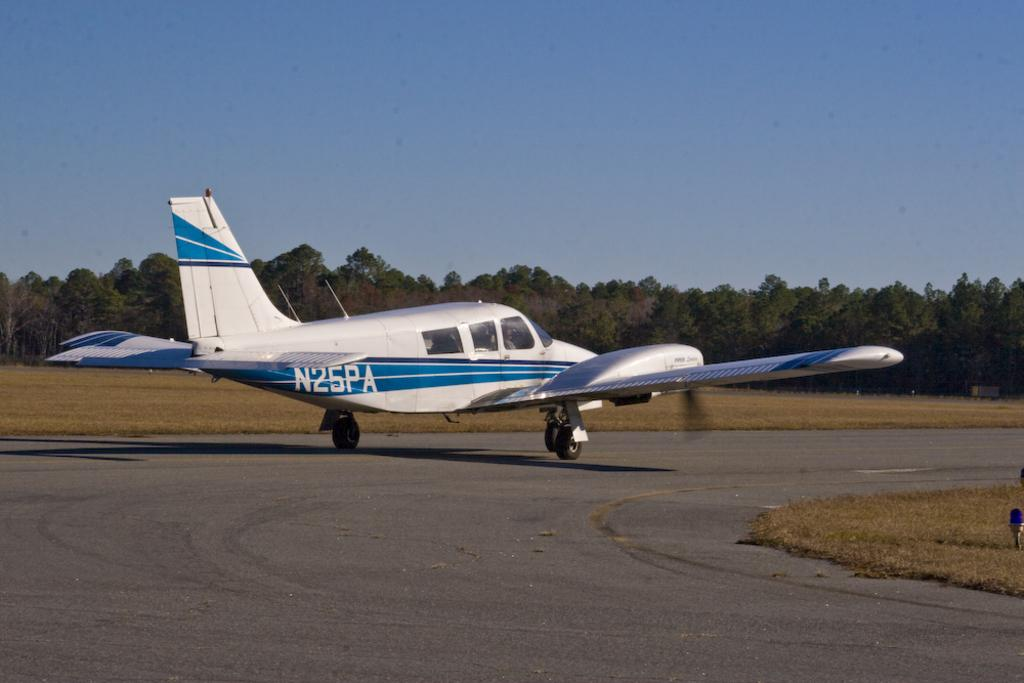What is the main subject of the image? The main subject of the image is an airplane. Can you describe any text on the airplane? Yes, there is text written on the airplane. What can be seen in the background of the image? There are trees in the background of the image. How would you describe the ground in the image? The ground is covered with dry grass. Where is the park located in the image? There is no park present in the image. Can you describe the coach that is parked next to the airplane? There is no coach present in the image; only the airplane and trees are visible. 